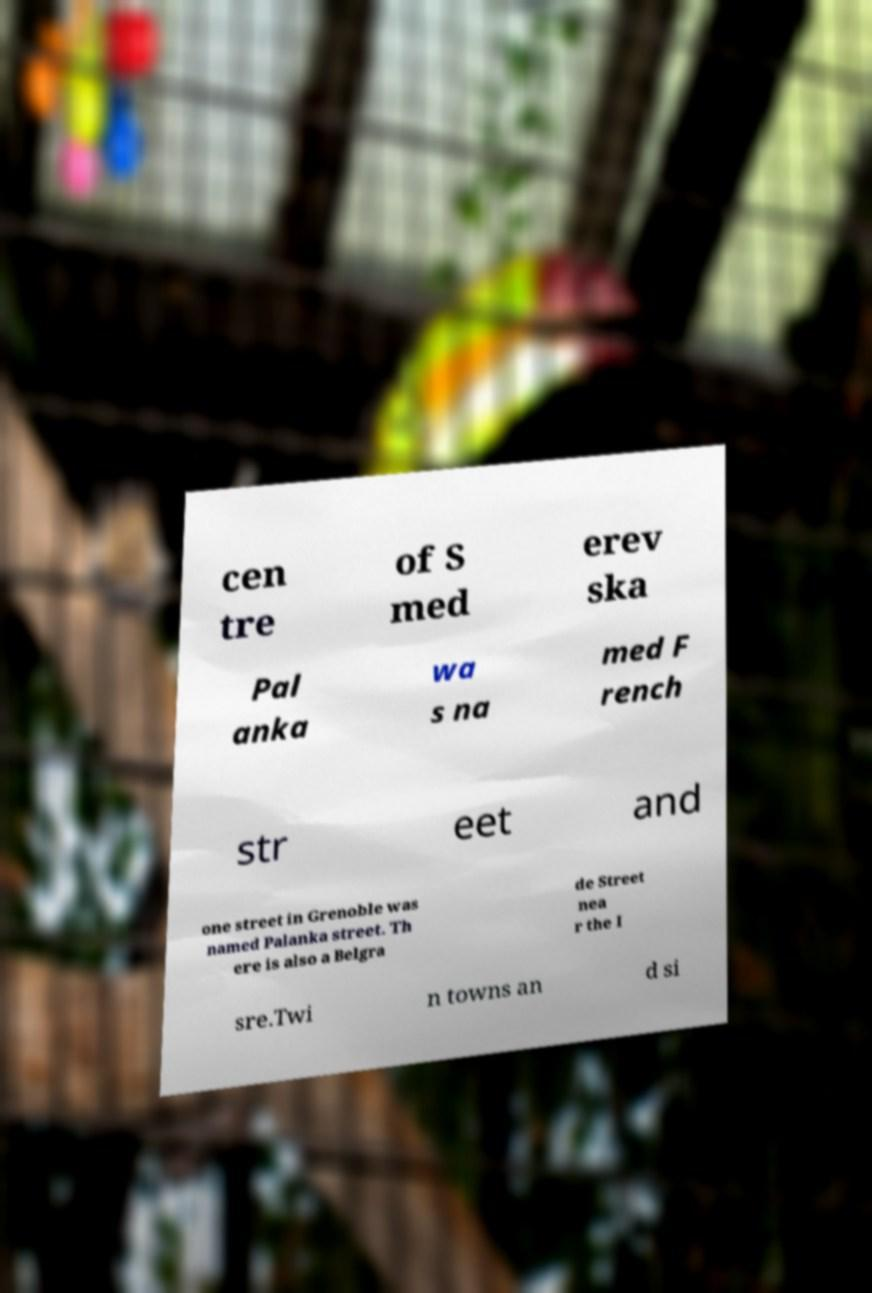What messages or text are displayed in this image? I need them in a readable, typed format. cen tre of S med erev ska Pal anka wa s na med F rench str eet and one street in Grenoble was named Palanka street. Th ere is also a Belgra de Street nea r the I sre.Twi n towns an d si 